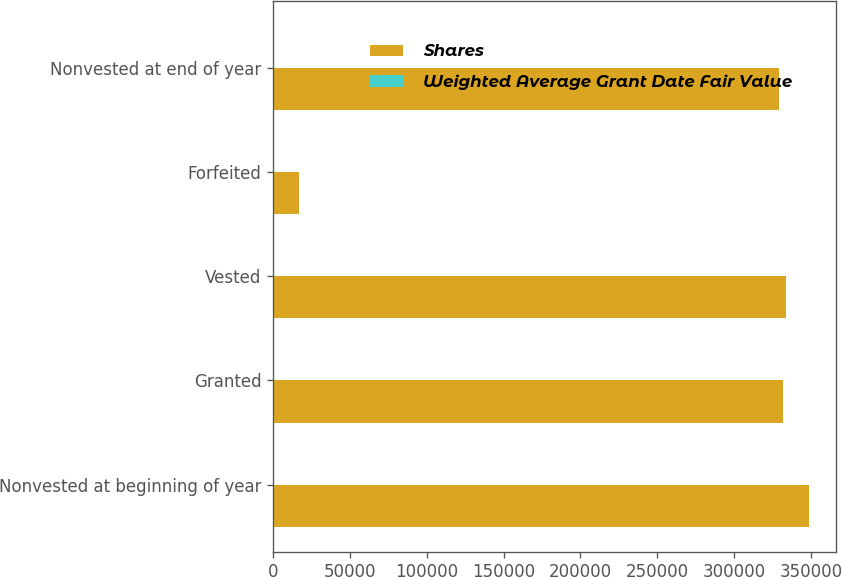<chart> <loc_0><loc_0><loc_500><loc_500><stacked_bar_chart><ecel><fcel>Nonvested at beginning of year<fcel>Granted<fcel>Vested<fcel>Forfeited<fcel>Nonvested at end of year<nl><fcel>Shares<fcel>348642<fcel>331533<fcel>333893<fcel>17156<fcel>329126<nl><fcel>Weighted Average Grant Date Fair Value<fcel>2.47<fcel>3.13<fcel>2.65<fcel>1.3<fcel>2.92<nl></chart> 